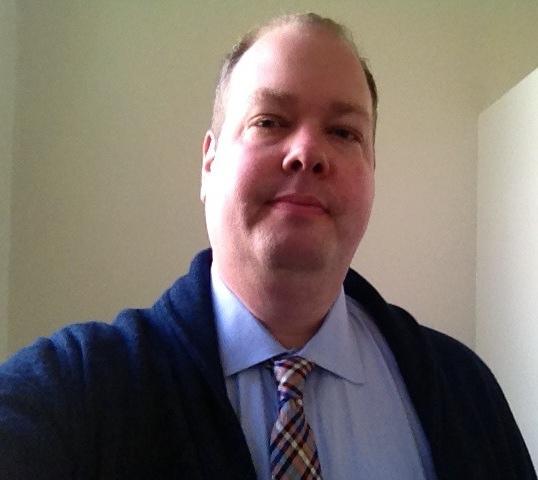Is this a child?
Write a very short answer. No. Does the man have facial hair?
Concise answer only. No. Is this the face of a man who needs to have a bowel movement?
Give a very brief answer. No. Is the man rich?
Concise answer only. No. Does the person have earphones?
Concise answer only. No. Is the man a blue-collared or white-collared worker?
Answer briefly. Blue. Does his tie have dots?
Write a very short answer. No. What kind of pattern is on his tie?
Answer briefly. Plaid. Is this man attractive?
Write a very short answer. No. What is the white line going down the middle of the tie?
Be succinct. Pattern. Has this man had his hair styled?
Be succinct. No. Is this man happy?
Short answer required. No. Where is he going?
Concise answer only. Work. What color is his shirt?
Keep it brief. Blue. What color is the tie?
Give a very brief answer. Plaid. Is there a picture in this image?
Concise answer only. No. Is the man wearing glasses?
Concise answer only. No. 